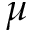<formula> <loc_0><loc_0><loc_500><loc_500>\mu</formula> 